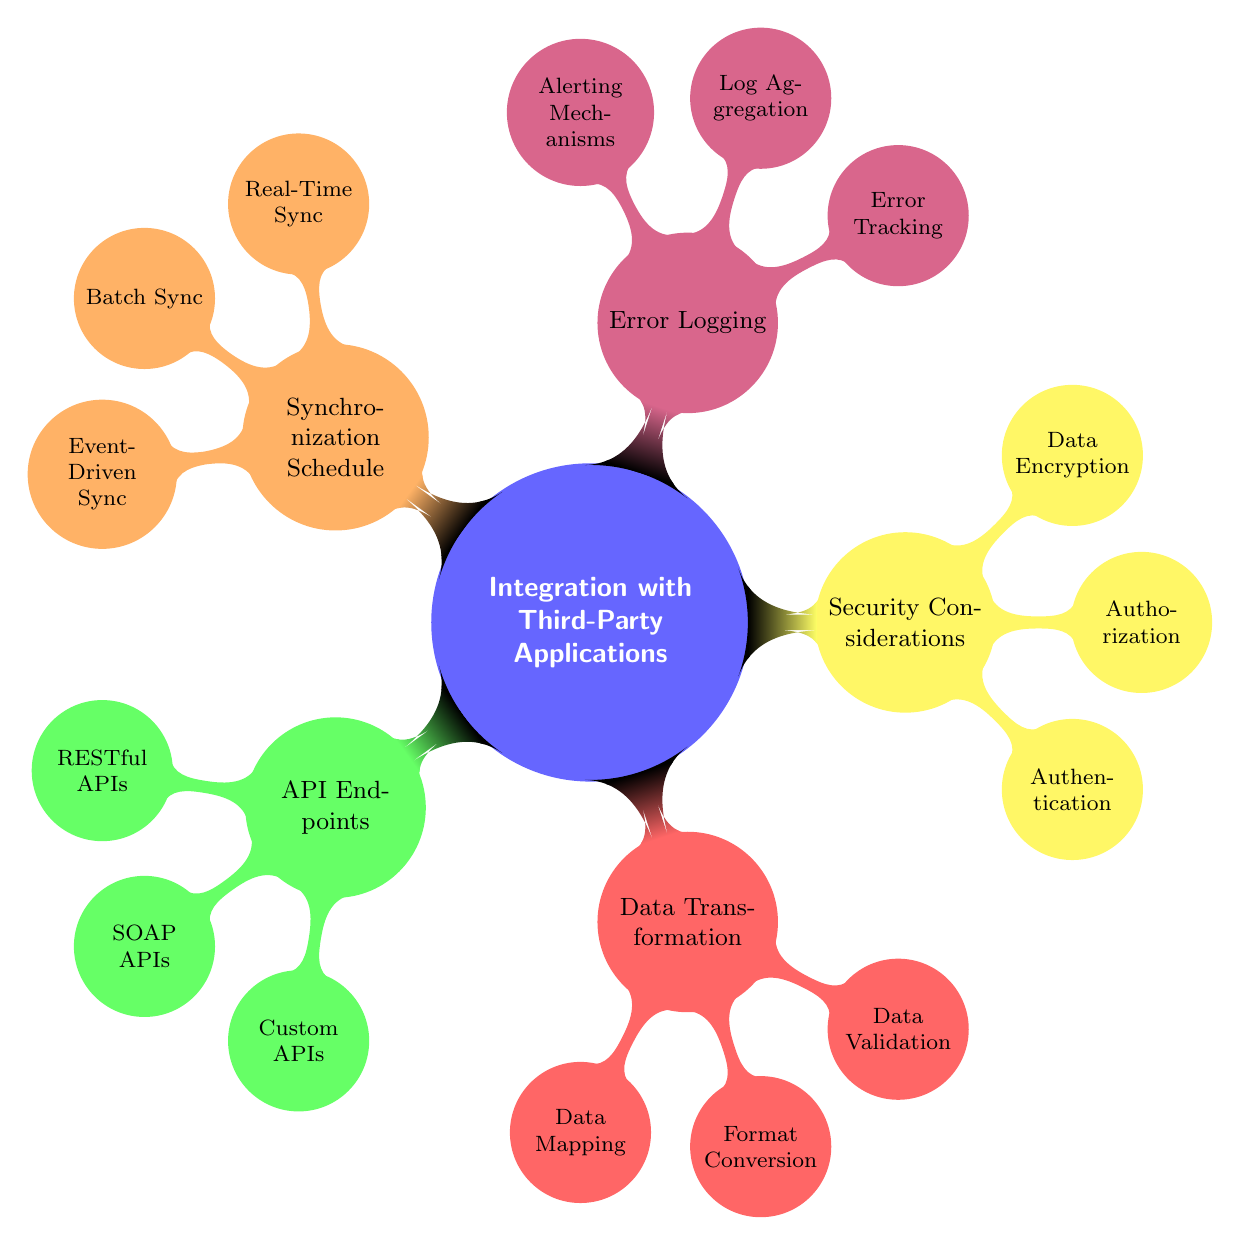What are the three types of API endpoints mentioned? The diagram lists "RESTful APIs," "SOAP APIs," and "Custom APIs" as the three types of API endpoints under the "API Endpoints" category.
Answer: RESTful APIs, SOAP APIs, Custom APIs How many nodes are there in the "Error Logging" category? The "Error Logging" category contains three nodes: "Error Tracking," "Log Aggregation," and "Alerting Mechanisms."
Answer: 3 Which part of the diagram discusses data validation? Data validation is discussed under the "Data Transformation" category, which includes "Data Validation" as one of its nodes.
Answer: Data Transformation What authentication method is specified in the diagram? The diagram specifies "OAuth2" as the authentication method listed under the "Security Considerations" category.
Answer: OAuth2 How does "Real-Time Sync" differ from "Batch Sync"? "Real-Time Sync," represented by "Webhooks," allows for immediate updates, while "Batch Sync," represented by "Daily Cron Jobs," operates on a scheduled basis.
Answer: Webhooks vs. Daily Cron Jobs What is the relationship between "Data Mapping" and "ETL Tools"? "Data Mapping" is related to "ETL Tools," specifically "Talend," which facilitates the data transformation process within this category.
Answer: ETL Tools - Talend Which synchronization method involves message queues? The synchronization method that involves message queues is termed "Event-Driven Sync," specifically using "RabbitMQ" as noted in the diagram.
Answer: Event-Driven Sync What color represents the "Synchronization Schedule" category? The "Synchronization Schedule" category is represented in the diagram by the color orange.
Answer: Orange 